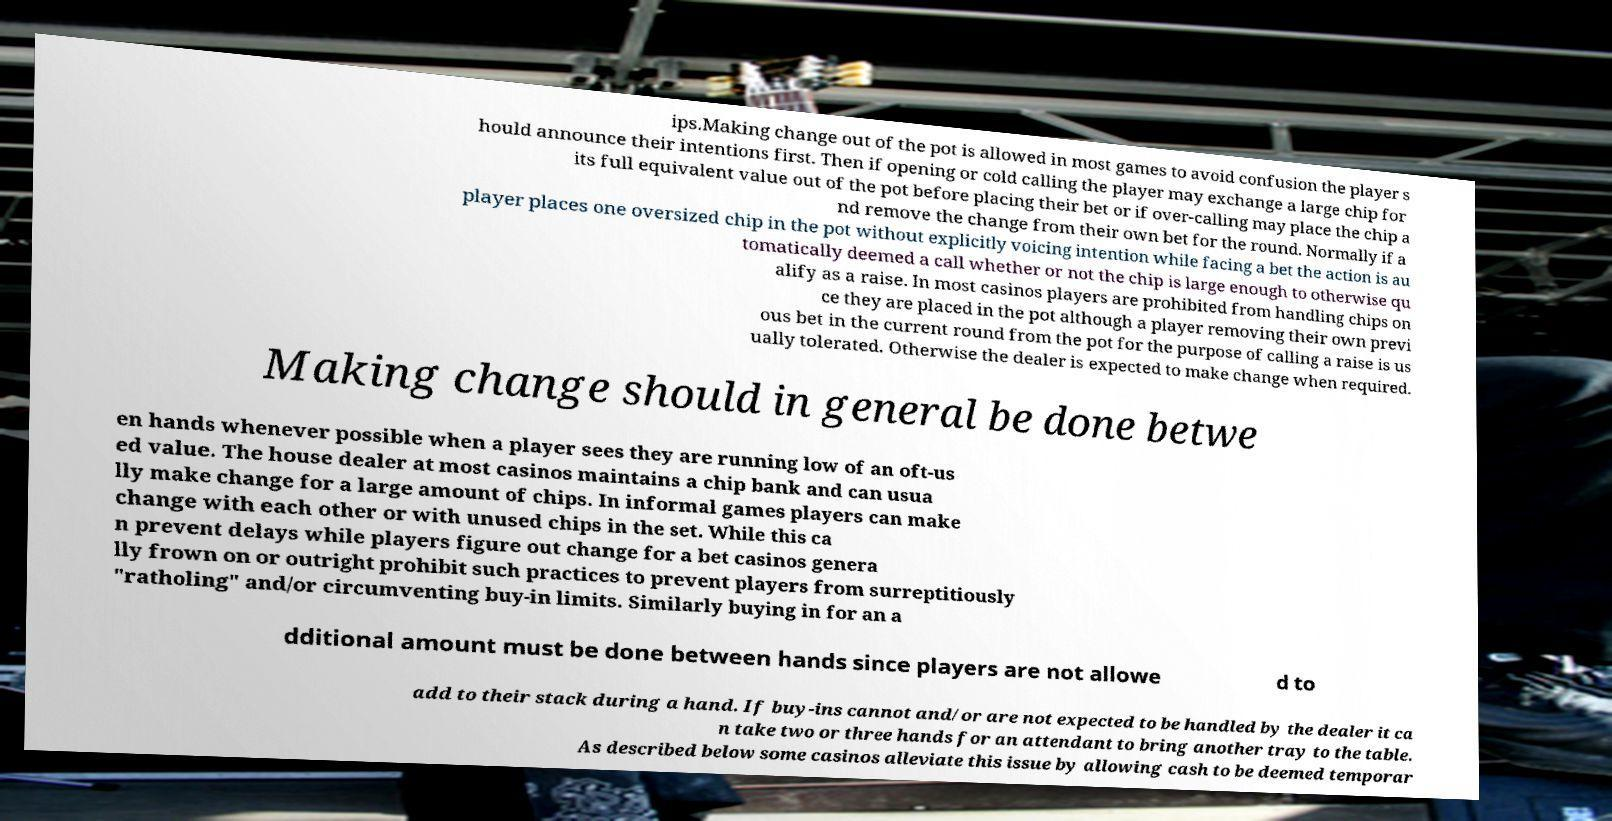Please read and relay the text visible in this image. What does it say? ips.Making change out of the pot is allowed in most games to avoid confusion the player s hould announce their intentions first. Then if opening or cold calling the player may exchange a large chip for its full equivalent value out of the pot before placing their bet or if over-calling may place the chip a nd remove the change from their own bet for the round. Normally if a player places one oversized chip in the pot without explicitly voicing intention while facing a bet the action is au tomatically deemed a call whether or not the chip is large enough to otherwise qu alify as a raise. In most casinos players are prohibited from handling chips on ce they are placed in the pot although a player removing their own previ ous bet in the current round from the pot for the purpose of calling a raise is us ually tolerated. Otherwise the dealer is expected to make change when required. Making change should in general be done betwe en hands whenever possible when a player sees they are running low of an oft-us ed value. The house dealer at most casinos maintains a chip bank and can usua lly make change for a large amount of chips. In informal games players can make change with each other or with unused chips in the set. While this ca n prevent delays while players figure out change for a bet casinos genera lly frown on or outright prohibit such practices to prevent players from surreptitiously "ratholing" and/or circumventing buy-in limits. Similarly buying in for an a dditional amount must be done between hands since players are not allowe d to add to their stack during a hand. If buy-ins cannot and/or are not expected to be handled by the dealer it ca n take two or three hands for an attendant to bring another tray to the table. As described below some casinos alleviate this issue by allowing cash to be deemed temporar 